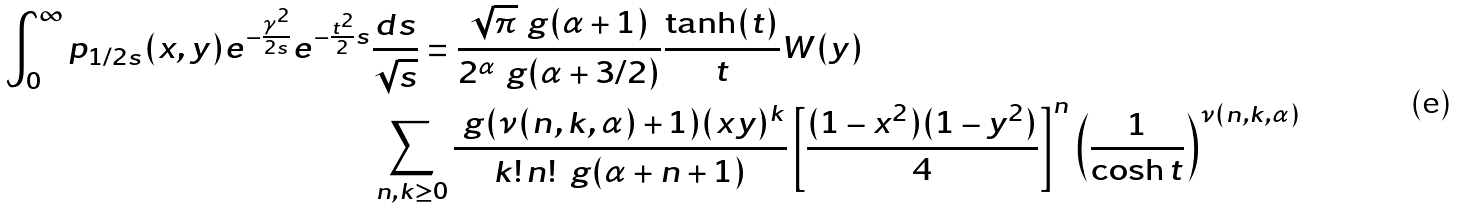Convert formula to latex. <formula><loc_0><loc_0><loc_500><loc_500>\int _ { 0 } ^ { \infty } p _ { 1 / 2 s } ( x , y ) e ^ { - \frac { \gamma ^ { 2 } } { 2 s } } e ^ { - \frac { t ^ { 2 } } { 2 } s } & \frac { d s } { \sqrt { s } } = \frac { \sqrt { \pi } \ g ( \alpha + 1 ) } { 2 ^ { \alpha } \ g ( \alpha + 3 / 2 ) } \frac { \tanh ( t ) } { t } W ( y ) \\ & \sum _ { n , k \geq 0 } \frac { \ g ( \nu ( n , k , \alpha ) + 1 ) ( x y ) ^ { k } } { k ! \, n ! \, \ g ( \alpha + n + 1 ) } \left [ \frac { ( 1 - x ^ { 2 } ) ( 1 - y ^ { 2 } ) } { 4 } \right ] ^ { n } \left ( \frac { 1 } { \cosh t } \right ) ^ { \nu ( n , k , \alpha ) }</formula> 